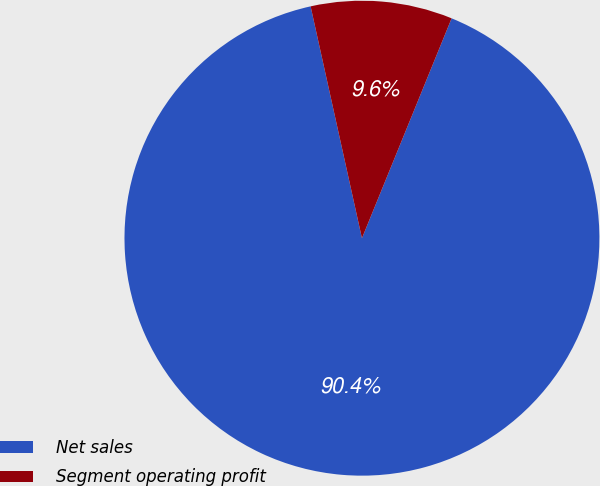Convert chart to OTSL. <chart><loc_0><loc_0><loc_500><loc_500><pie_chart><fcel>Net sales<fcel>Segment operating profit<nl><fcel>90.37%<fcel>9.63%<nl></chart> 